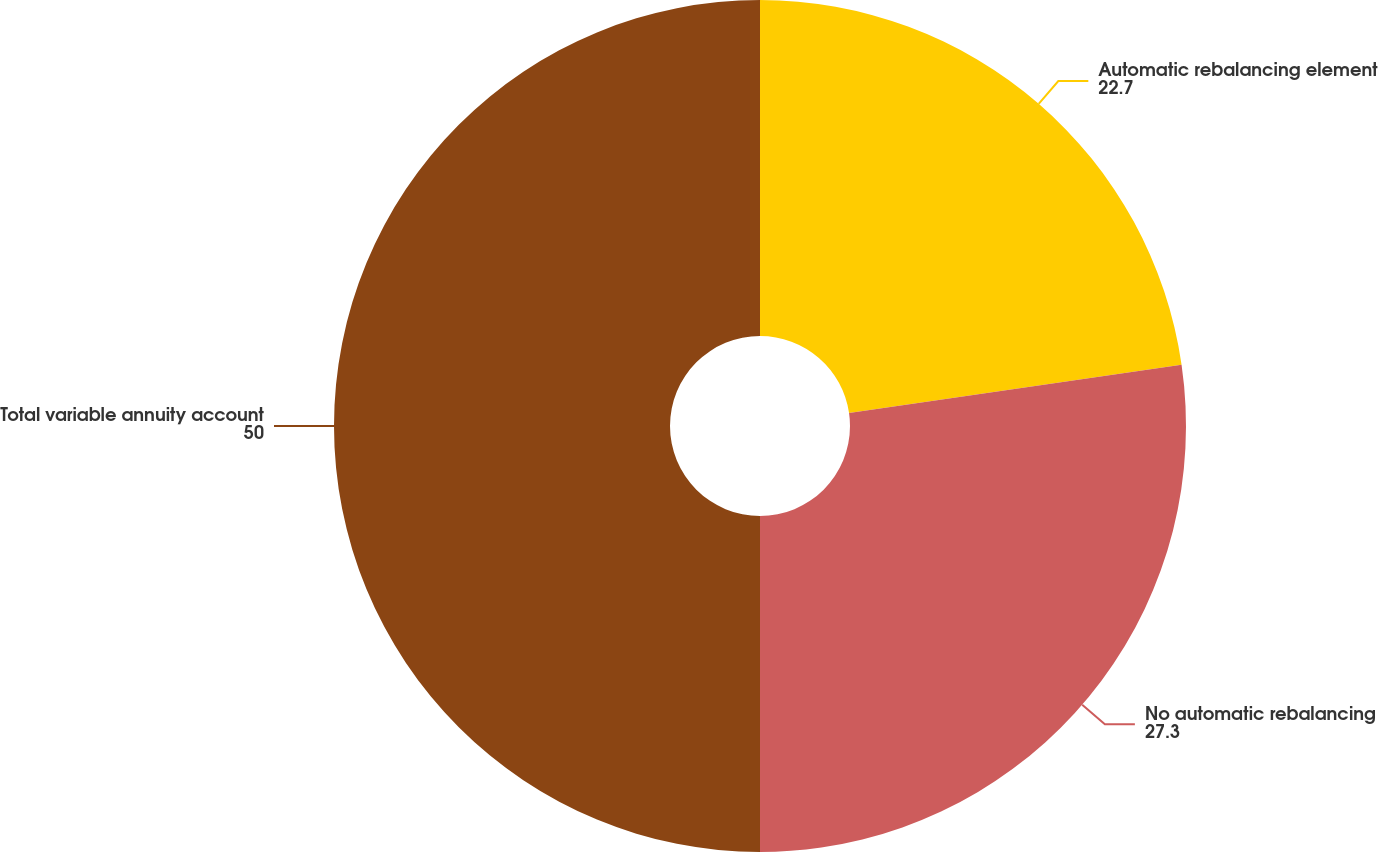Convert chart. <chart><loc_0><loc_0><loc_500><loc_500><pie_chart><fcel>Automatic rebalancing element<fcel>No automatic rebalancing<fcel>Total variable annuity account<nl><fcel>22.7%<fcel>27.3%<fcel>50.0%<nl></chart> 